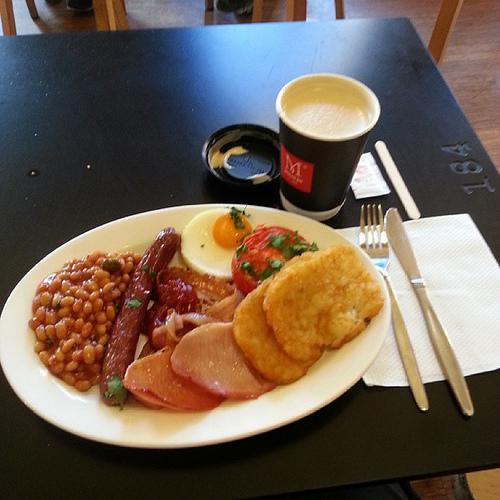Question: why is the cup uncovered?
Choices:
A. To pour and share with someone else.
B. To put ice in.
C. They were out of cup covers.
D. To keep it cool.
Answer with the letter. Answer: D Question: what is on the cup?
Choices:
A. Coffee.
B. Tea.
C. Soda.
D. Water.
Answer with the letter. Answer: A Question: when is this photo taken?
Choices:
A. In the evening.
B. In the morning.
C. At night.
D. At sunset.
Answer with the letter. Answer: B 